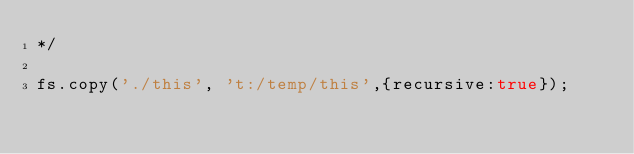Convert code to text. <code><loc_0><loc_0><loc_500><loc_500><_JavaScript_>*/

fs.copy('./this', 't:/temp/this',{recursive:true});


</code> 